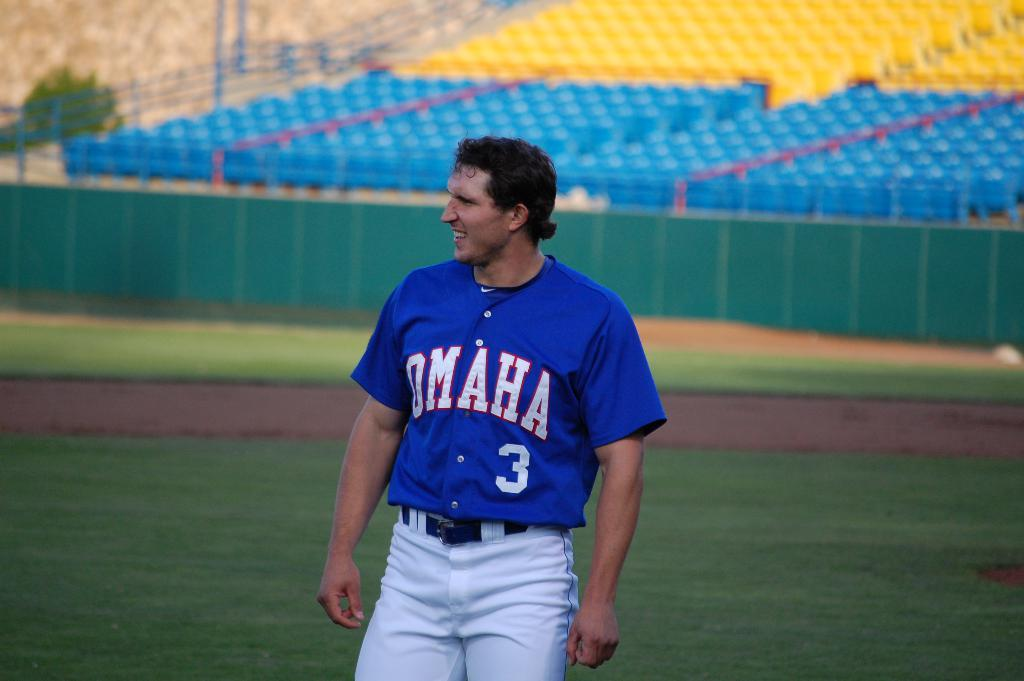<image>
Present a compact description of the photo's key features. A PLAYER FOR OMAHA IN A BLUE JERSEY NUMBERED THREE ON THE FIELD 